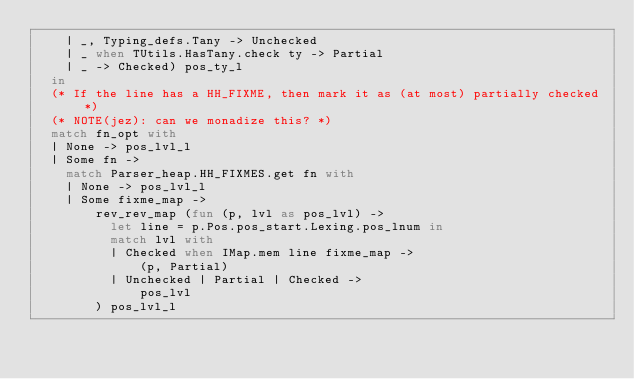<code> <loc_0><loc_0><loc_500><loc_500><_OCaml_>    | _, Typing_defs.Tany -> Unchecked
    | _ when TUtils.HasTany.check ty -> Partial
    | _ -> Checked) pos_ty_l
  in
  (* If the line has a HH_FIXME, then mark it as (at most) partially checked *)
  (* NOTE(jez): can we monadize this? *)
  match fn_opt with
  | None -> pos_lvl_l
  | Some fn ->
    match Parser_heap.HH_FIXMES.get fn with
    | None -> pos_lvl_l
    | Some fixme_map ->
        rev_rev_map (fun (p, lvl as pos_lvl) ->
          let line = p.Pos.pos_start.Lexing.pos_lnum in
          match lvl with
          | Checked when IMap.mem line fixme_map ->
              (p, Partial)
          | Unchecked | Partial | Checked ->
              pos_lvl
        ) pos_lvl_l
</code> 